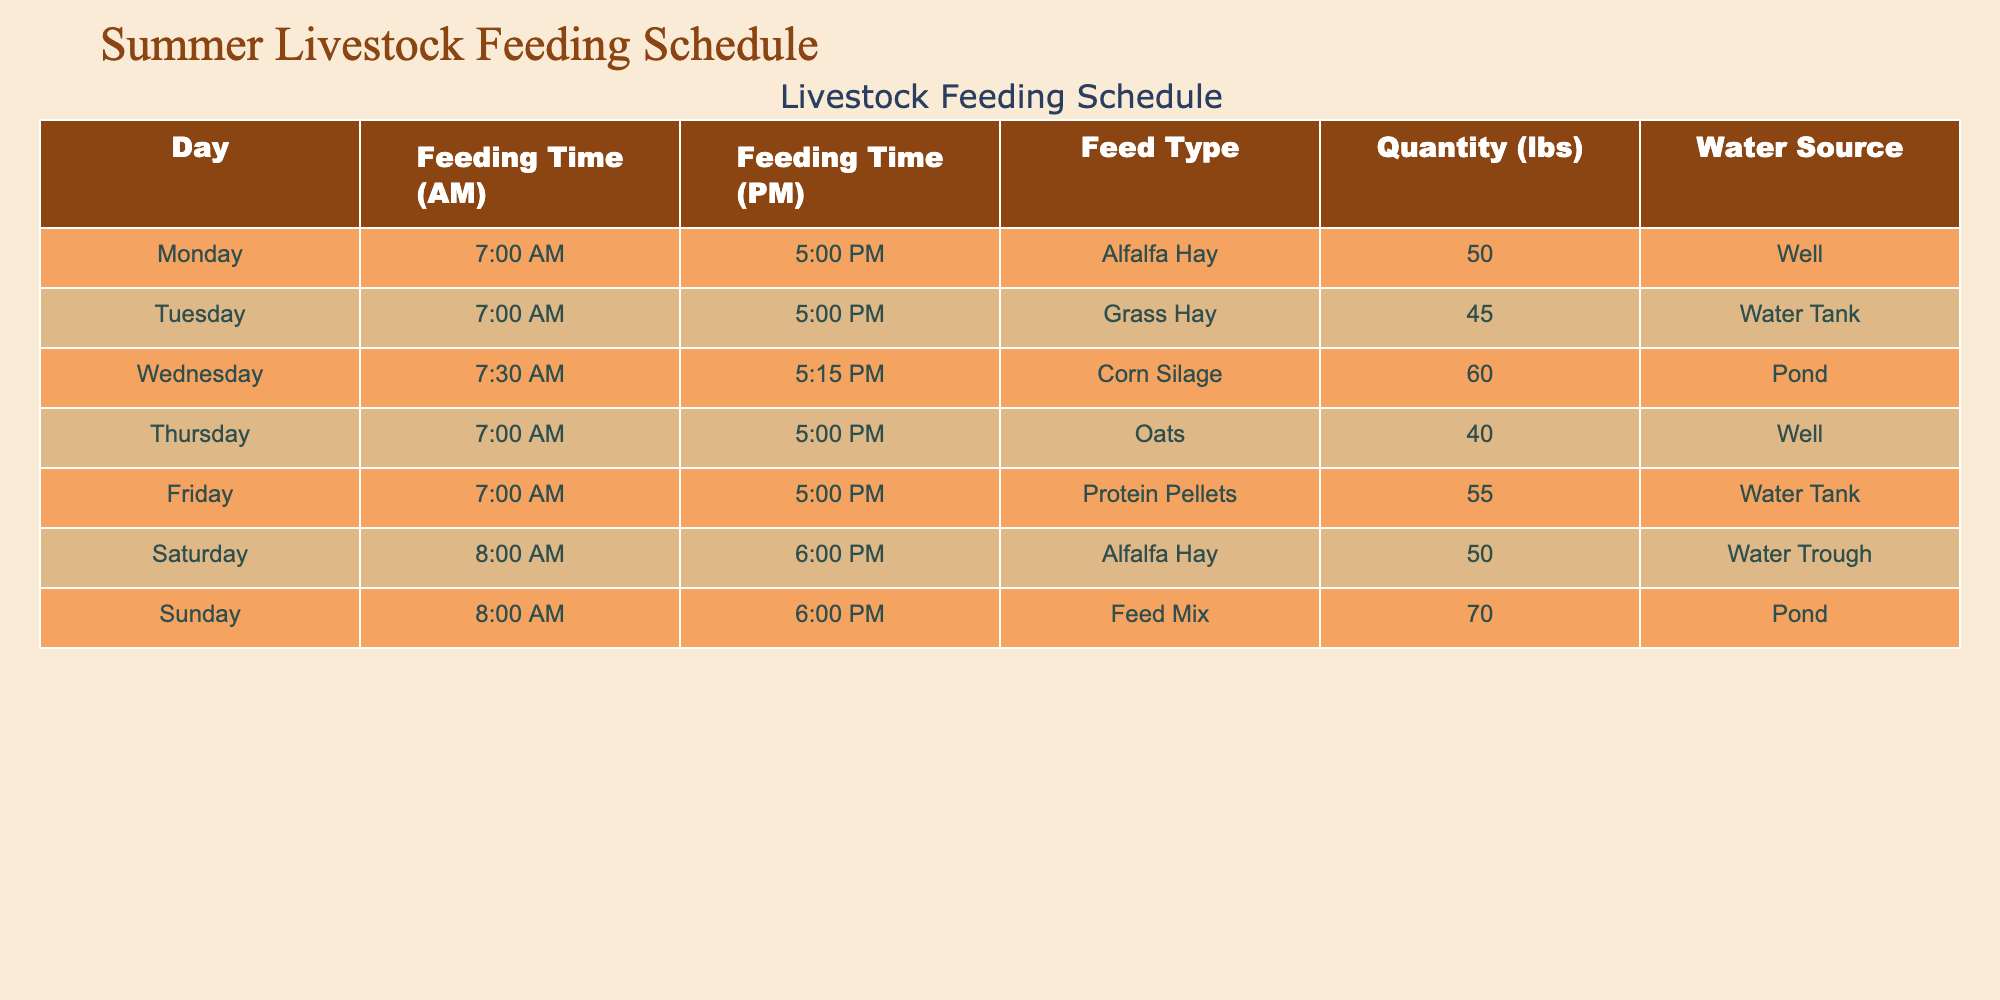What time is the first feeding on Friday? According to the table, the feeding time (AM) on Friday is listed as 7:00 AM.
Answer: 7:00 AM What is the quantity of Corn Silage fed on Wednesday? The table shows that the quantity of Corn Silage fed on Wednesday is 60 lbs.
Answer: 60 lbs Which type of feed is given on Sunday? Looking at the table, the feed type listed for Sunday is Feed Mix.
Answer: Feed Mix Which water source is used for feeding on Tuesday? The table indicates that on Tuesday, the water source for feeding is the Water Tank.
Answer: Water Tank What is the average quantity of feed given daily during the week? To find the average, sum the quantities of all feeds: 50 + 45 + 60 + 40 + 55 + 50 + 70 = 370 lbs. There are 7 days, so the average is 370 / 7 = approximately 52.86 lbs.
Answer: 52.86 lbs Is the feeding time consistent for the AM slot throughout the week? By examining the AM feeding times, we see that only Monday, Tuesday, Thursday, and Friday maintain a consistent 7:00 AM feeding time, while Wednesday and the weekend have different times, thus it is not consistent.
Answer: No On which day is the latest feeding in the PM slot? By reviewing the table, Saturday and Sunday have the latest feeding time of 6:00 PM, which is later than all other days.
Answer: Saturday and Sunday How much more Alfalfa Hay is fed than Oats in total across their feeding days? Alfalfa Hay is fed on Monday and Saturday (50 + 50 = 100 lbs total), while Oats is fed on Thursday (40 lbs). To find the difference, subtract the total Oats quantity from Alfalfa Hay total: 100 - 40 = 60 lbs.
Answer: 60 lbs Does the amount of Protein Pellets exceed that of Grass Hay? Protein Pellets feeding quantity is 55 lbs on Friday, while Grass Hay feeding quantity is 45 lbs on Tuesday. Since 55 lbs is greater than 45 lbs, the statement is true.
Answer: Yes 